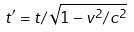Convert formula to latex. <formula><loc_0><loc_0><loc_500><loc_500>t ^ { \prime } = t / \sqrt { 1 - v ^ { 2 } / c ^ { 2 } }</formula> 